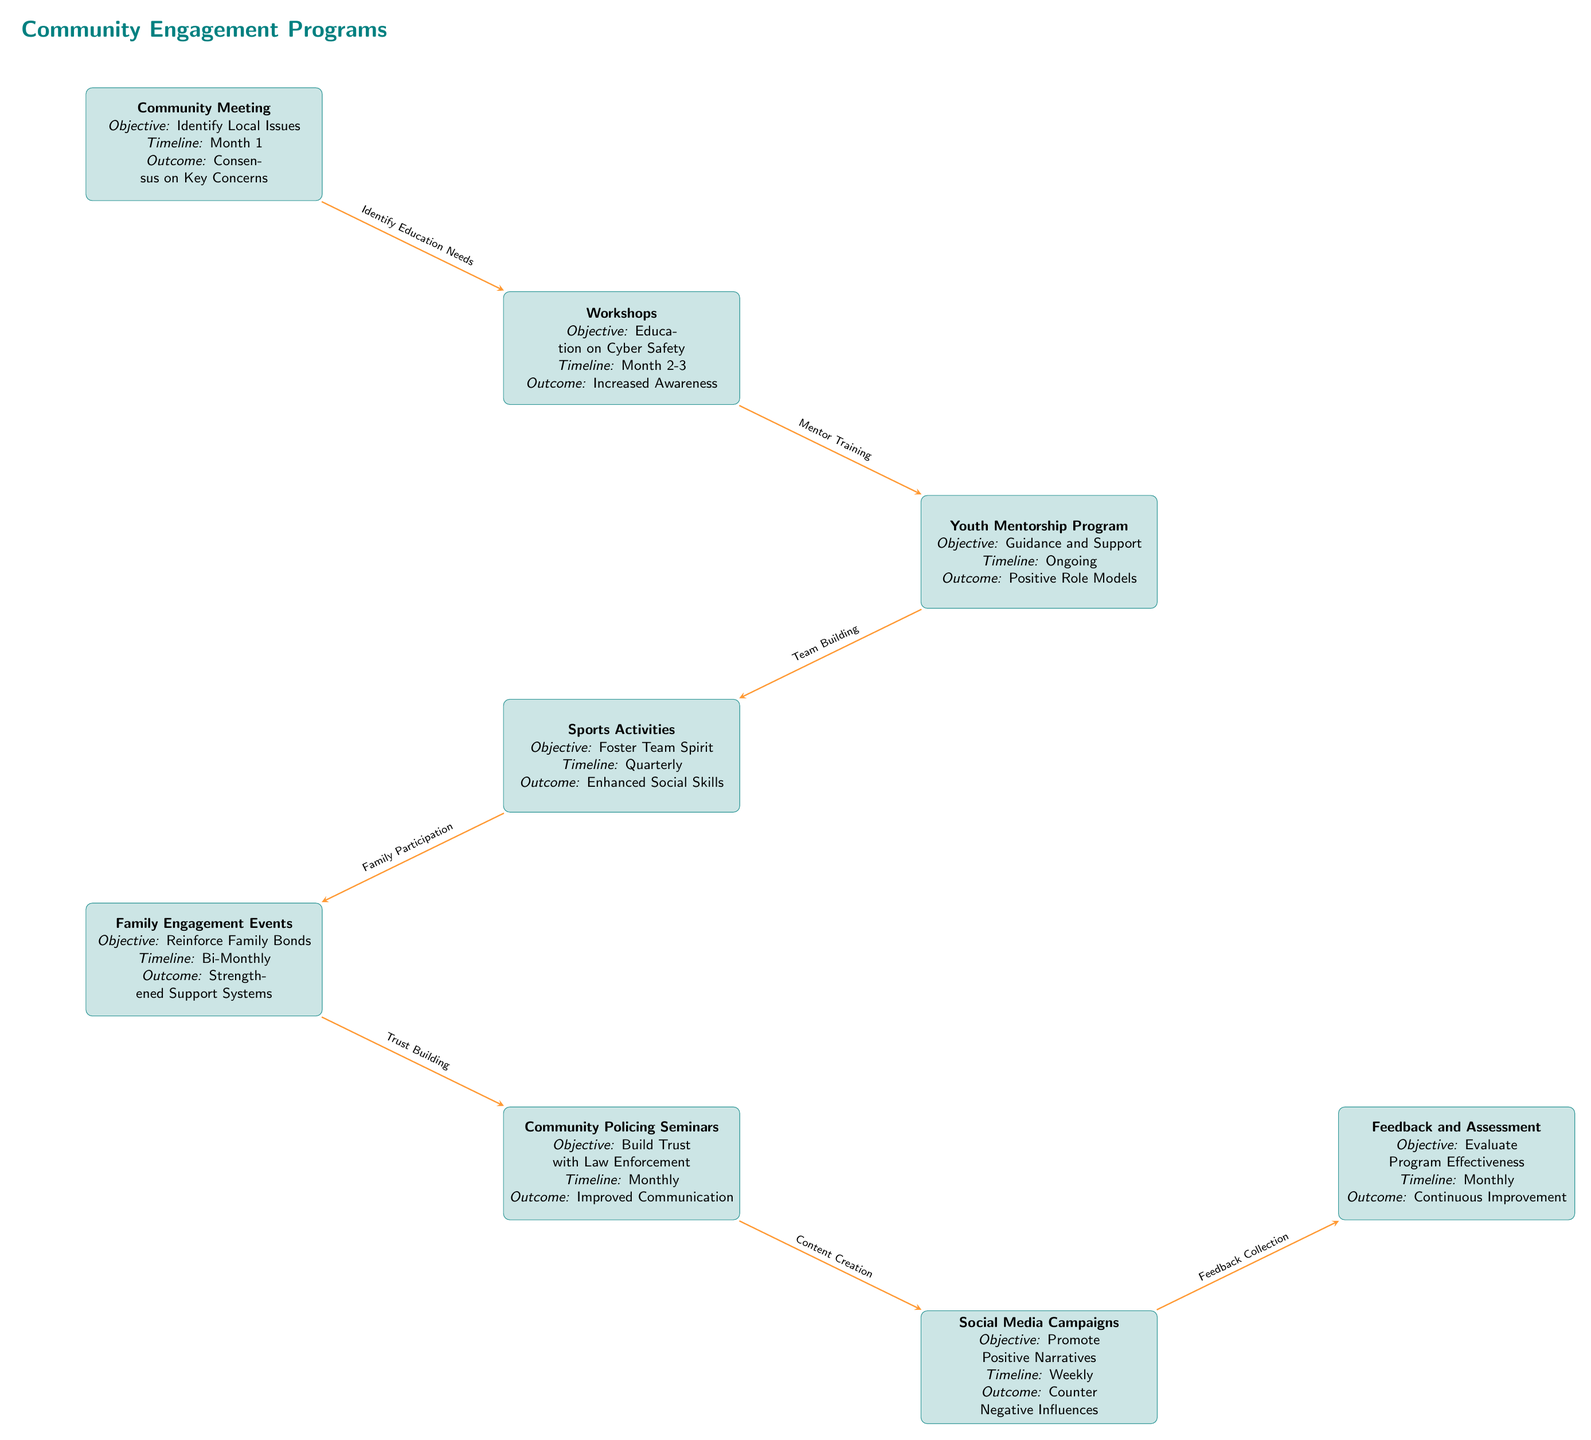What is the objective of the Community Meeting? The objective listed in the Community Meeting box is to identify local issues.
Answer: Identify Local Issues What is the outcome of the Youth Mentorship Program? The outcome displayed in the Youth Mentorship Program box is positive role models.
Answer: Positive Role Models How many nodes are represented in the flowchart? By counting each activity represented in the flowchart, there are eight distinct nodes, each depicting a different community engagement activity.
Answer: Eight What relationship describes the connection between Workshops and Youth Mentorship Program? The arrow connecting Workshops to Youth Mentorship Program is labeled as "Mentor Training," indicating that the Workshops are designed to facilitate the training needed for effective mentorship.
Answer: Mentor Training What is the timeline for Family Engagement Events? In the Family Engagement Events box, the timeline is specified as 'Bi-Monthly'.
Answer: Bi-Monthly Which activity aims to build trust with law enforcement? The activity directly aimed at building trust with law enforcement is labeled as Community Policing Seminars.
Answer: Community Policing Seminars What is the objective of Social Media Campaigns? The objective of Social Media Campaigns, as stated in the respective box, is to promote positive narratives.
Answer: Promote Positive Narratives What is the effect of the Feedback and Assessment activity? The indicated effect of Feedback and Assessment in the diagram is continuous improvement, emphasizing the importance of evaluating programs to enhance their effectiveness.
Answer: Continuous Improvement What is the timeline for Sports Activities? The timeline for Sports Activities is detailed as Quarterly, meaning these activities are scheduled to occur every three months.
Answer: Quarterly What combined objective do the Sports Activities and Family Engagement Events share? Both activities aim to foster social connections and supportive environments, illustrated by their focus on team spirit and family bonds respectively, leading to enhanced social skills and strengthened support systems.
Answer: Foster Social Connections 